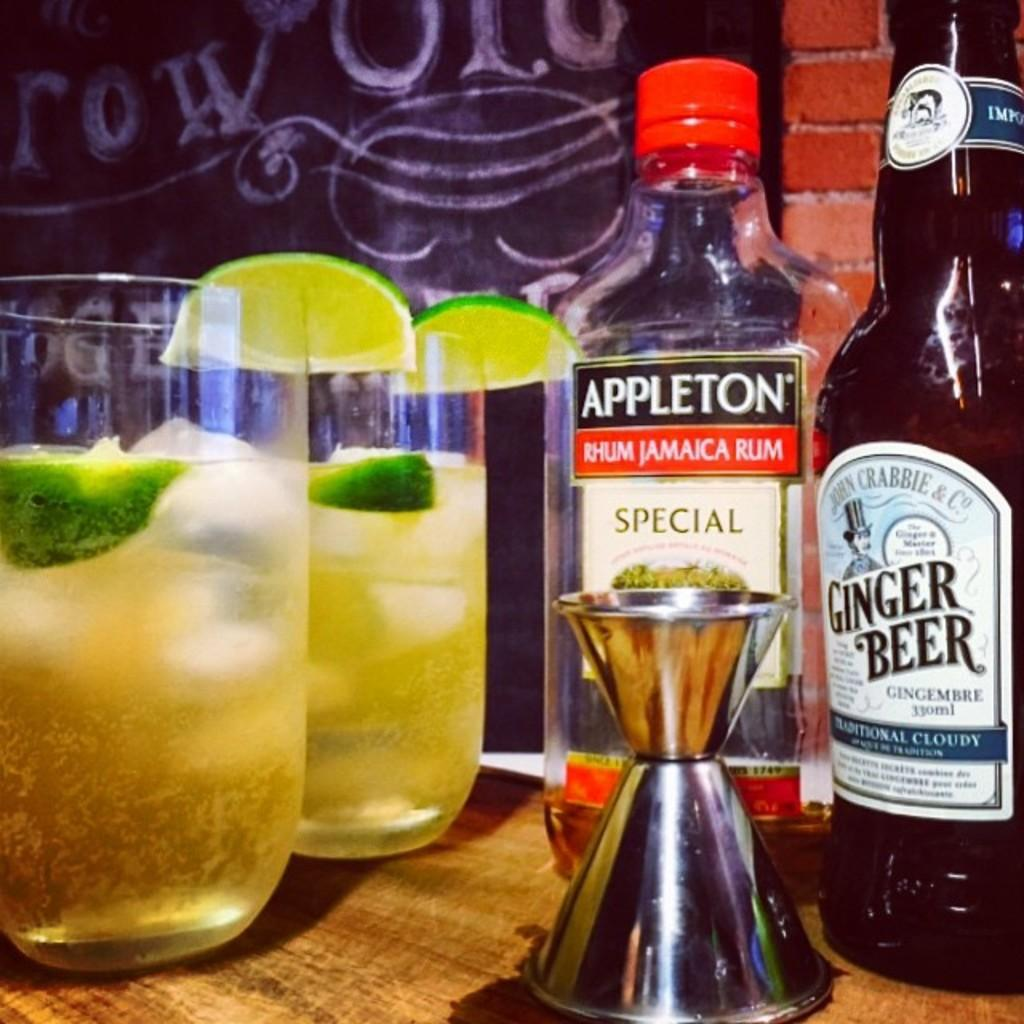<image>
Present a compact description of the photo's key features. A bottle of jamaican rum and ginger beer next to two other cups. 